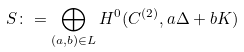<formula> <loc_0><loc_0><loc_500><loc_500>S \colon = \bigoplus _ { ( a , b ) \in L } H ^ { 0 } ( C ^ { ( 2 ) } , a \Delta + b K )</formula> 